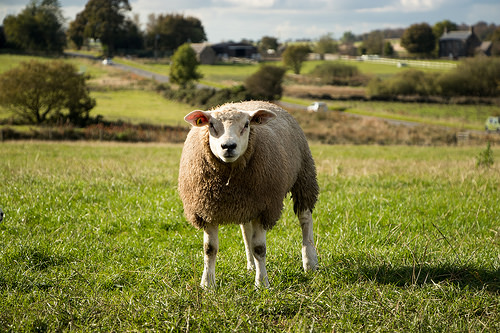<image>
Is the sheep on the grass? Yes. Looking at the image, I can see the sheep is positioned on top of the grass, with the grass providing support. Is there a sheep in front of the tree? Yes. The sheep is positioned in front of the tree, appearing closer to the camera viewpoint. 